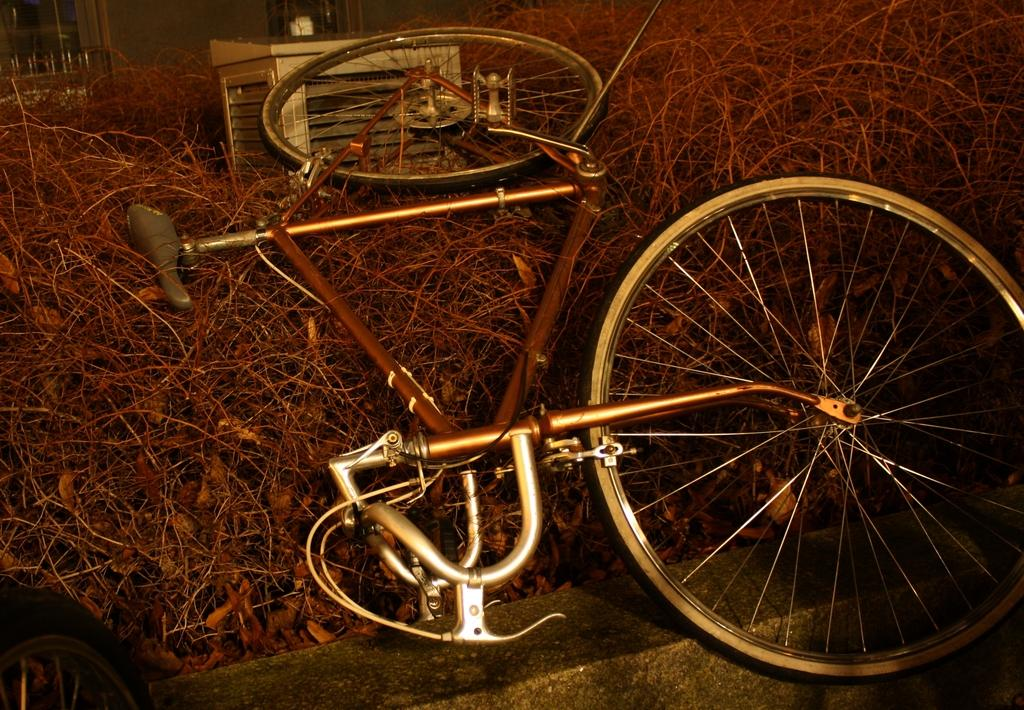What is the main object in the center of the image? There is a bicycle in the center of the image. What is placed on the twigs in the image? There is a box on the twigs. Can you identify any part of the bicycle in the image? A tire is visible in the image. What type of structure can be seen in the image? There is a wall in the image. What can be seen in the background of the image? Windows are present in the background of the image. What type of game is being played on the bicycle in the image? There is no game being played on the bicycle in the image; it is simply a stationary object. What role does glue play in the image? There is no mention of glue in the image, so it does not play any role. 